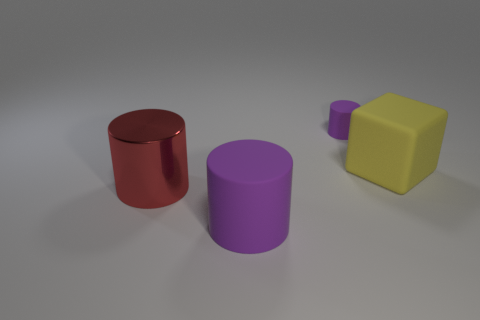Are there any tiny purple cylinders on the right side of the big yellow matte block?
Offer a very short reply. No. Is the number of rubber objects greater than the number of yellow matte cubes?
Offer a very short reply. Yes. What color is the large matte object that is behind the big cylinder that is behind the purple rubber cylinder left of the small purple cylinder?
Your response must be concise. Yellow. The big cylinder that is the same material as the cube is what color?
Your answer should be very brief. Purple. Is there any other thing that has the same size as the cube?
Your response must be concise. Yes. What number of objects are purple matte cylinders left of the tiny rubber object or big things that are on the left side of the big yellow rubber block?
Give a very brief answer. 2. Do the rubber cylinder that is to the left of the tiny purple matte thing and the purple cylinder that is behind the rubber cube have the same size?
Provide a short and direct response. No. There is another tiny object that is the same shape as the red object; what is its color?
Keep it short and to the point. Purple. Are there any other things that have the same shape as the small purple matte object?
Offer a very short reply. Yes. Are there more things that are behind the large red thing than big purple cylinders behind the large purple matte thing?
Provide a succinct answer. Yes. 